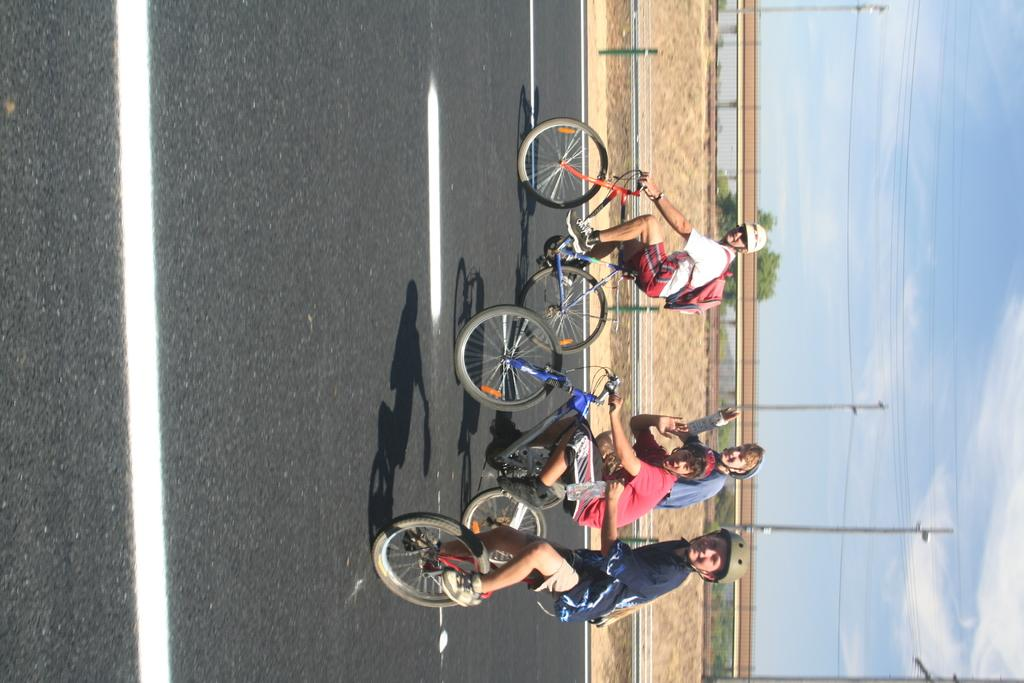What are the people in the image doing? The people in the image are riding bicycles on the road. What can be seen in the background of the image? In the background, there is a fence, the ground, a pole with wires, trees, and the sky. How many people are riding bicycles in the image? The number of people riding bicycles is not specified, but there are at least two people visible. What type of transportation is not present in the image? Trains are not present in the image. What type of donkey is sorting the wires on the pole in the image? There is no donkey present in the image, and the wires on the pole are not being sorted. 